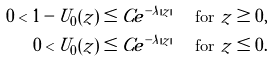<formula> <loc_0><loc_0><loc_500><loc_500>0 < 1 - U _ { 0 } ( z ) & \leq C e ^ { - \lambda | z | } \quad \text { for } z \geq 0 , \\ 0 < U _ { 0 } ( z ) & \leq C e ^ { - \lambda | z | } \quad \text { for } z \leq 0 .</formula> 